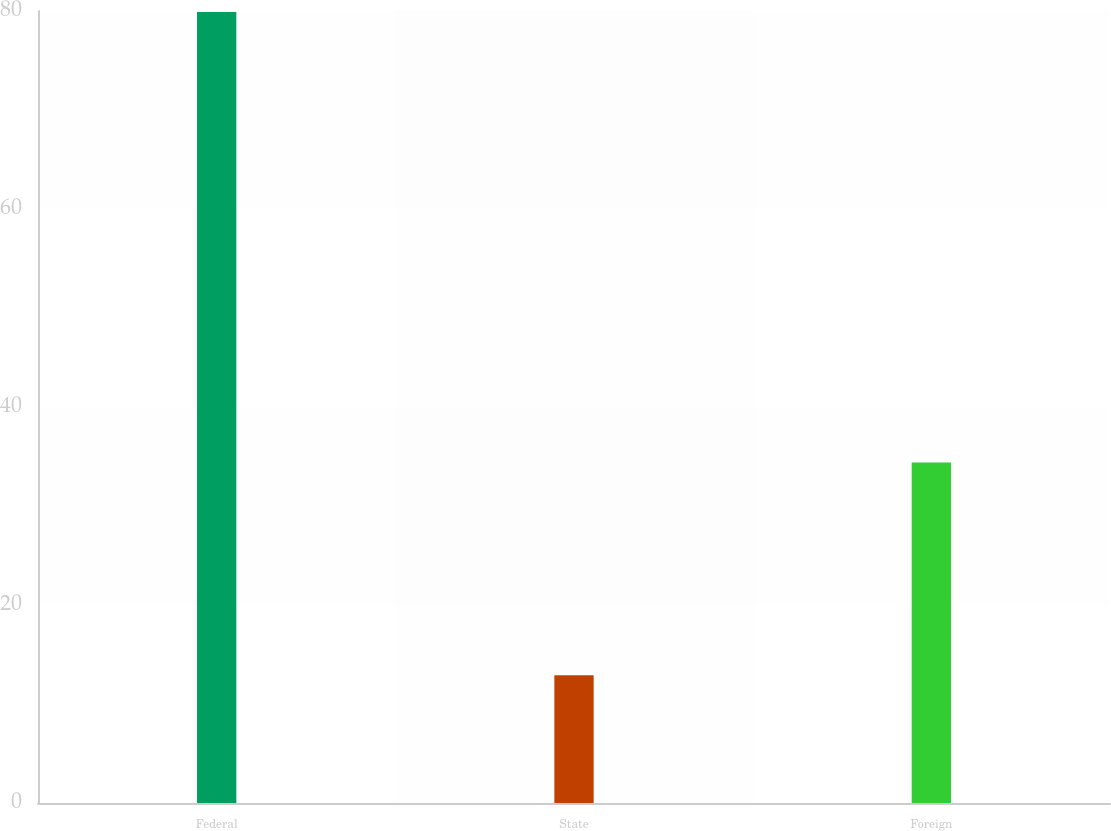<chart> <loc_0><loc_0><loc_500><loc_500><bar_chart><fcel>Federal<fcel>State<fcel>Foreign<nl><fcel>79.9<fcel>12.9<fcel>34.4<nl></chart> 